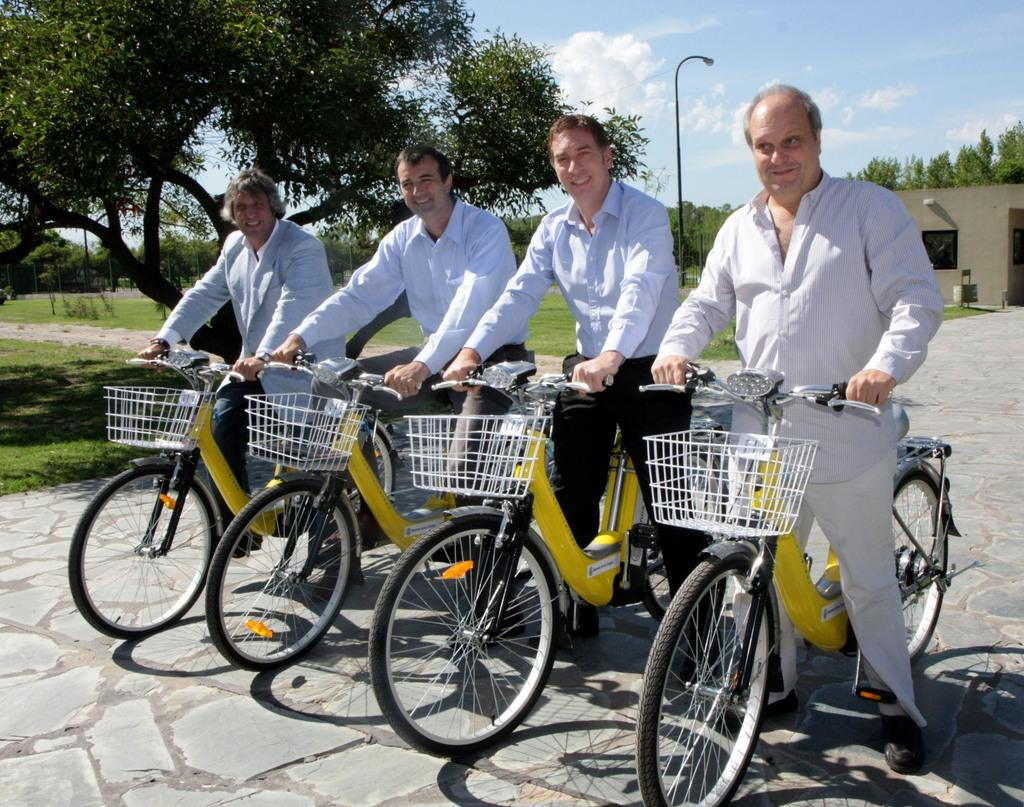How many people are in the image? There are four persons in the image. What are the persons doing in the image? The persons are sitting on a cycle. What is the facial expression of the persons? The persons are smiling. What can be seen in the background of the image? There are trees and sky visible in the background of the image. What is located in the center of the image? There is a pole in the center of the image. What type of haircut is the person on the left side of the image getting? There is no haircut being performed in the image; the persons are sitting on a cycle and smiling. What tool is the person on the right side of the image using to fix the cycle? There is no tool visible in the image; the persons are simply sitting on the cycle and smiling. 